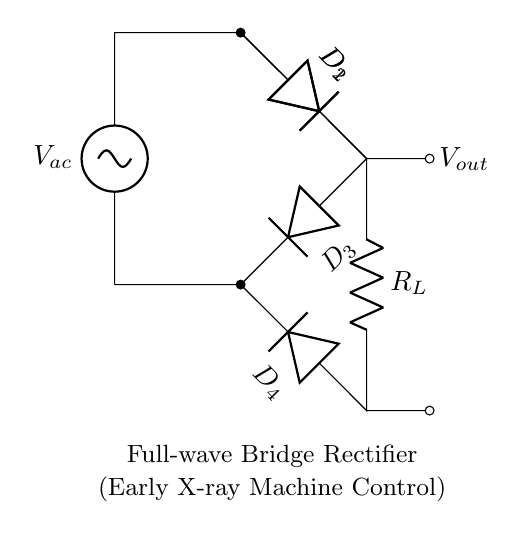What type of rectifier is shown in the circuit? The diagram depicts a Full-wave Bridge Rectifier, as indicated by the arrangement of diodes which allows current to flow through both halves of the AC cycle.
Answer: Full-wave Bridge Rectifier How many diodes are used in this circuit? The diagram shows four diodes labeled D1, D2, D3, and D4, which collectively form the bridge rectifier.
Answer: Four What is the function of the load resistor labeled in the circuit? The load resistor, denoted as R_L, is used to draw current from the rectified output voltage, simulating a load for the circuit.
Answer: To draw current What is the expected output voltage behavior of this circuit? The output voltage will be pulsating DC, as the Full-wave Bridge Rectifier converts AC input into a continuous voltage output by rectifying both halves of the input waveform.
Answer: Pulsating DC Which component controls the direction of current flow in this circuit? The diodes D1, D2, D3, and D4 control the direction of current flow by allowing current to pass only in one direction, thereby rectifying the AC input.
Answer: Diodes How does a Full-wave Bridge Rectifier affect ripple voltage compared to a half-wave rectifier? The Full-wave Bridge Rectifier produces less ripple voltage than a half-wave rectifier, resulting in a smoother DC output due to the utilization of both halves of the AC waveform.
Answer: Less ripple voltage What happens to the voltage if one diode in the bridge fails? If one diode fails, the circuit will still allow current to flow but will only output half-wave rectification, leading to a reduced output voltage and increased ripple.
Answer: Reduced output voltage 